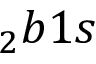<formula> <loc_0><loc_0><loc_500><loc_500>_ { 2 } b 1 s</formula> 